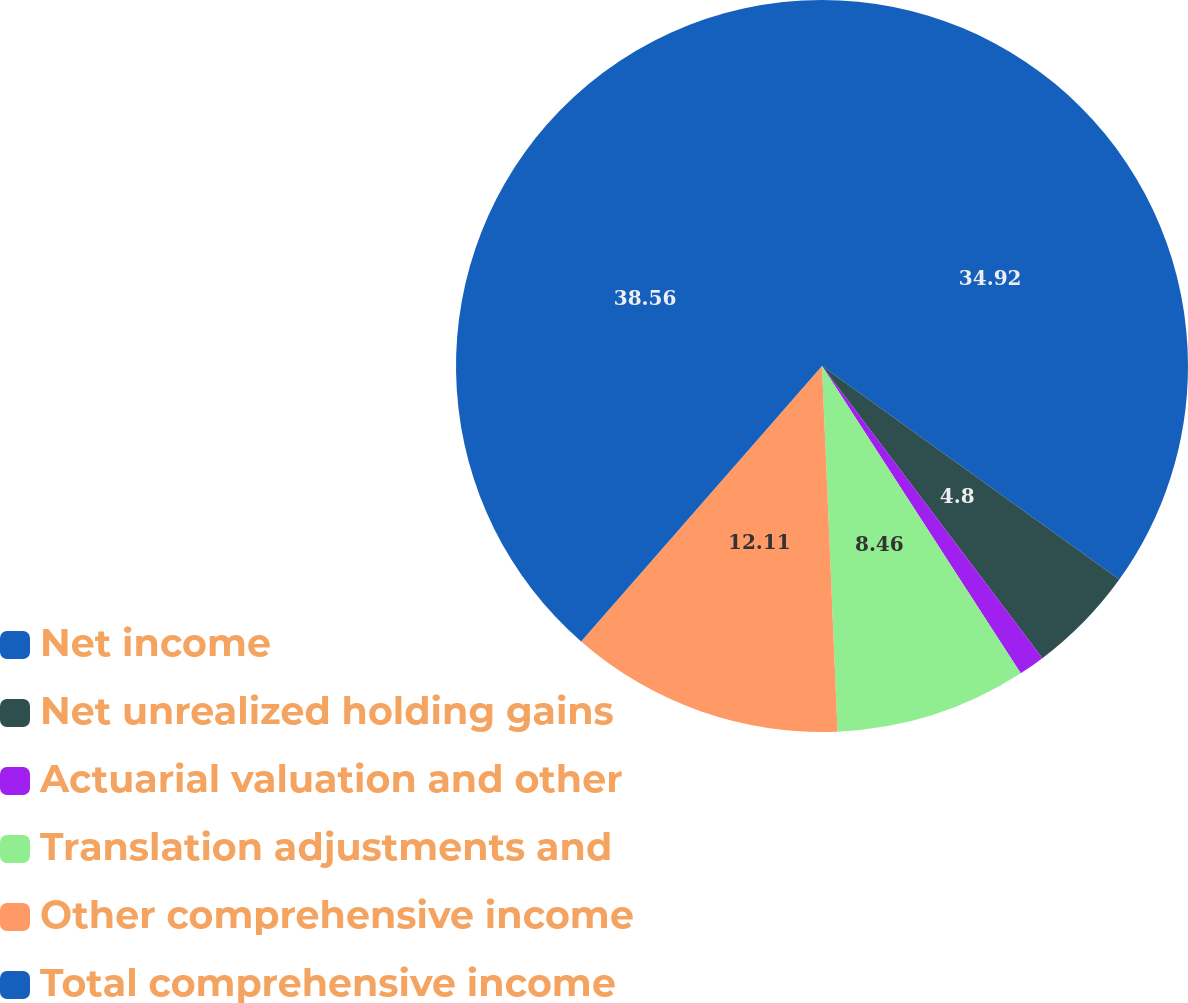Convert chart to OTSL. <chart><loc_0><loc_0><loc_500><loc_500><pie_chart><fcel>Net income<fcel>Net unrealized holding gains<fcel>Actuarial valuation and other<fcel>Translation adjustments and<fcel>Other comprehensive income<fcel>Total comprehensive income<nl><fcel>34.92%<fcel>4.8%<fcel>1.15%<fcel>8.46%<fcel>12.11%<fcel>38.57%<nl></chart> 